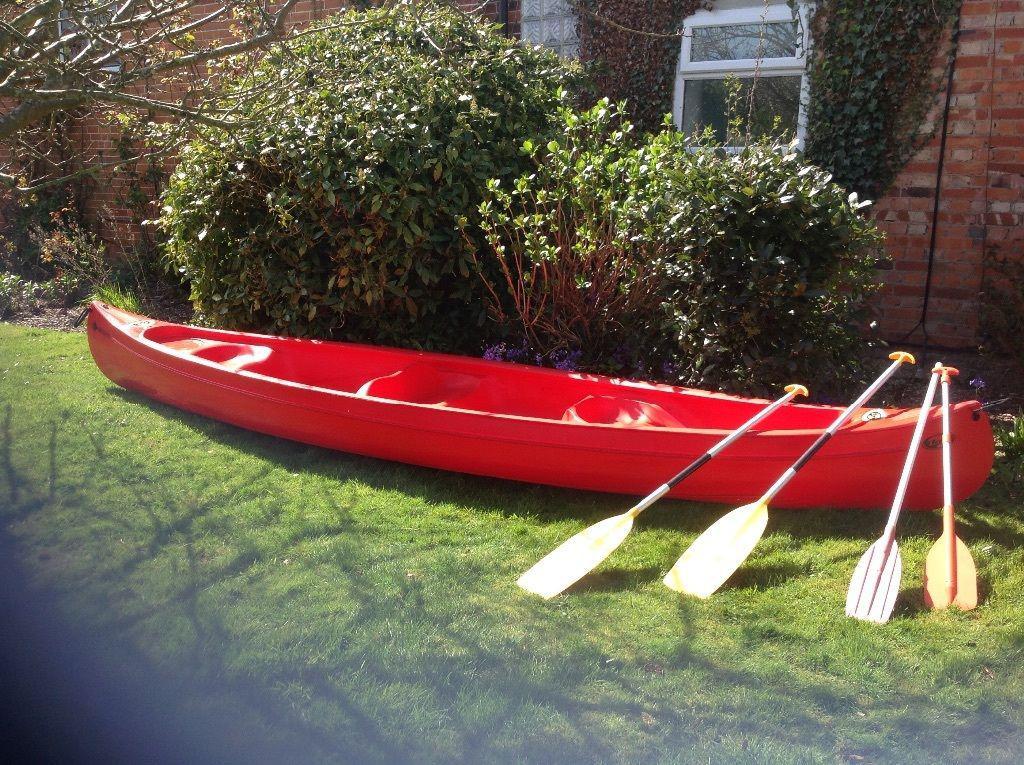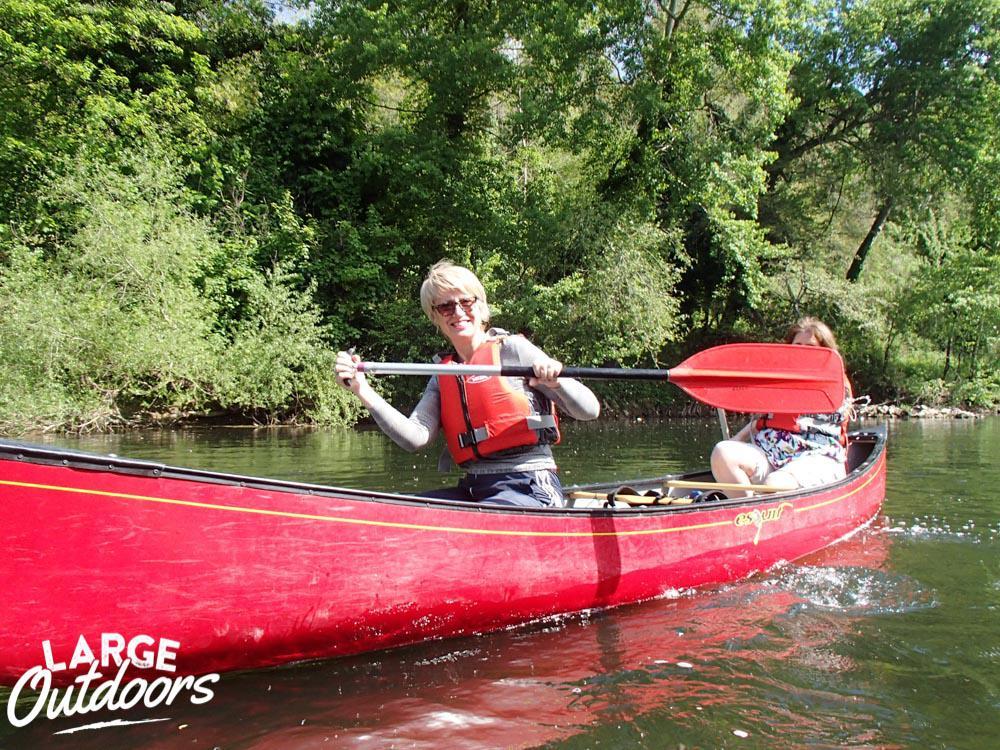The first image is the image on the left, the second image is the image on the right. Examine the images to the left and right. Is the description "A person is in the water in a red kayak in the image on the right." accurate? Answer yes or no. Yes. 